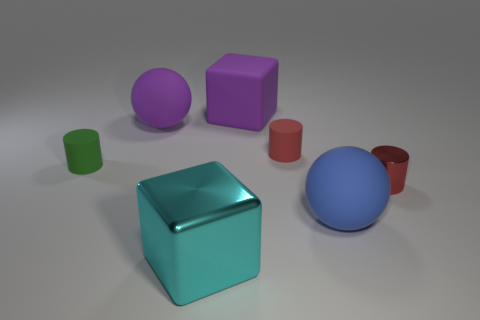Add 3 matte objects. How many objects exist? 10 Subtract all cylinders. How many objects are left? 4 Subtract 0 red cubes. How many objects are left? 7 Subtract all big shiny blocks. Subtract all blue spheres. How many objects are left? 5 Add 3 purple matte balls. How many purple matte balls are left? 4 Add 7 big cyan things. How many big cyan things exist? 8 